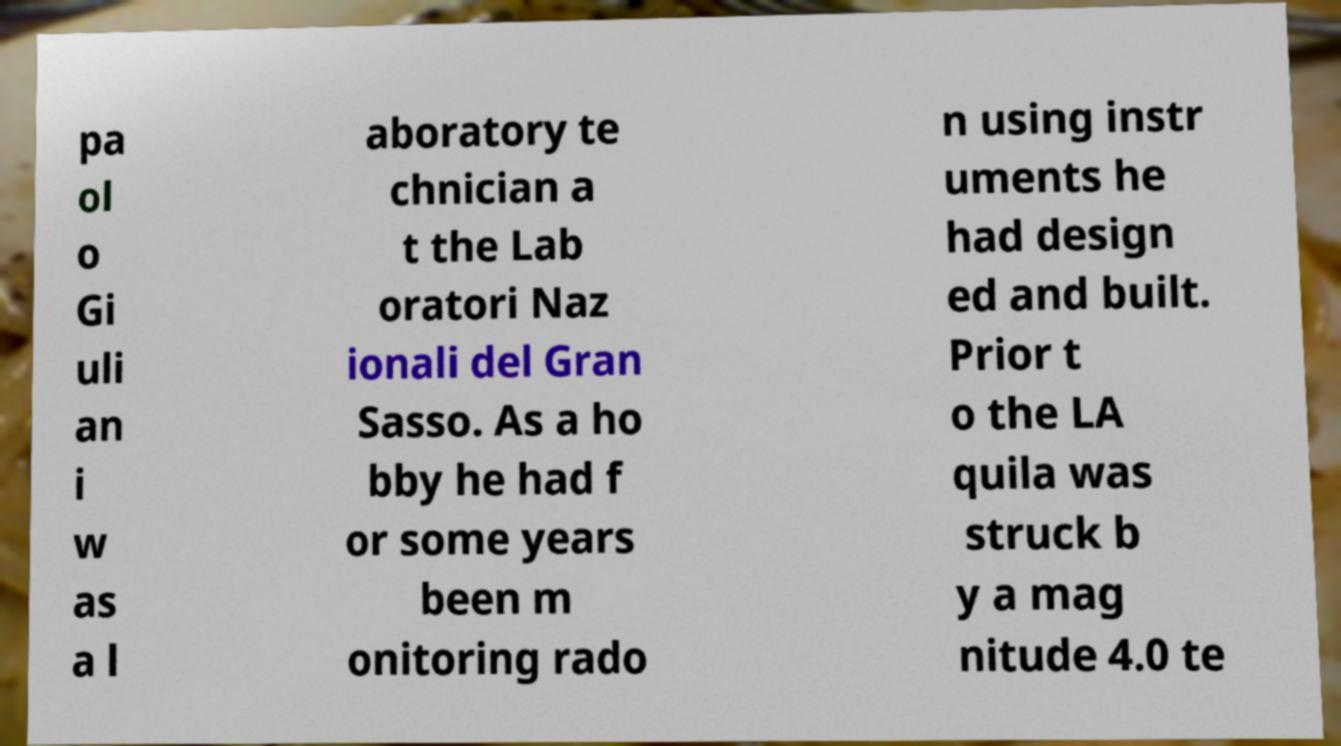Can you accurately transcribe the text from the provided image for me? pa ol o Gi uli an i w as a l aboratory te chnician a t the Lab oratori Naz ionali del Gran Sasso. As a ho bby he had f or some years been m onitoring rado n using instr uments he had design ed and built. Prior t o the LA quila was struck b y a mag nitude 4.0 te 